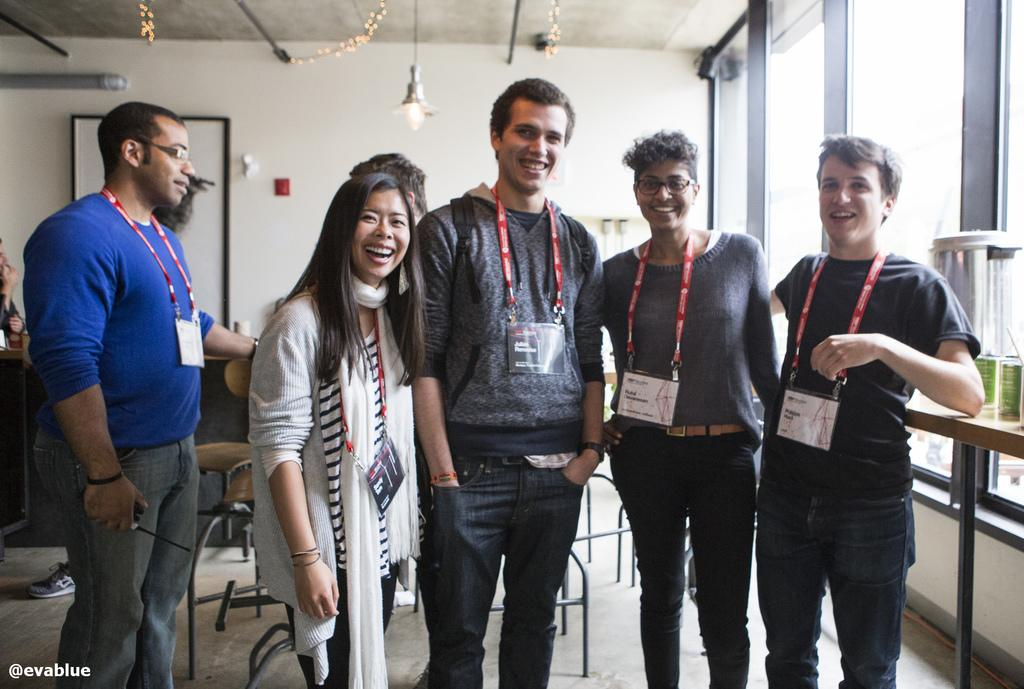What is the main subject of the image? The main subject of the image is a group of people. What are the people wearing in the image? The people are wearing ID cards in the image. What is the facial expression of the people in the image? The people are smiling in the image. What type of furniture is present in the image? There are chairs and tables in the image. What is hanging from the ceiling in the image? There are lamps on the ceiling in the image. How many cows are present in the image? There are no cows present in the image; it features a group of people. What type of friend is standing next to the person in the image? There is no specific friend mentioned or identifiable in the image; it only shows a group of people wearing ID cards and smiling. 